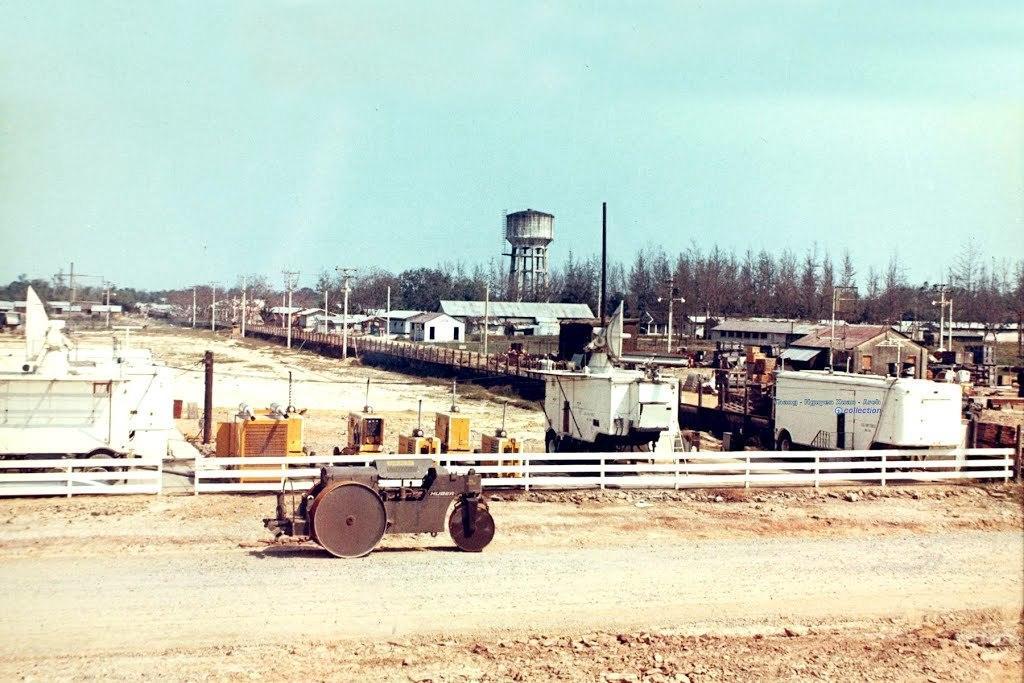Please provide a concise description of this image. This image consists of a road roller. At the bottom, there is a road. In the background, there is a fencing in white color. And there are many machines. On the right, there are houses along with the trees. In the background, we can see a tank. At the top, there is sky. 